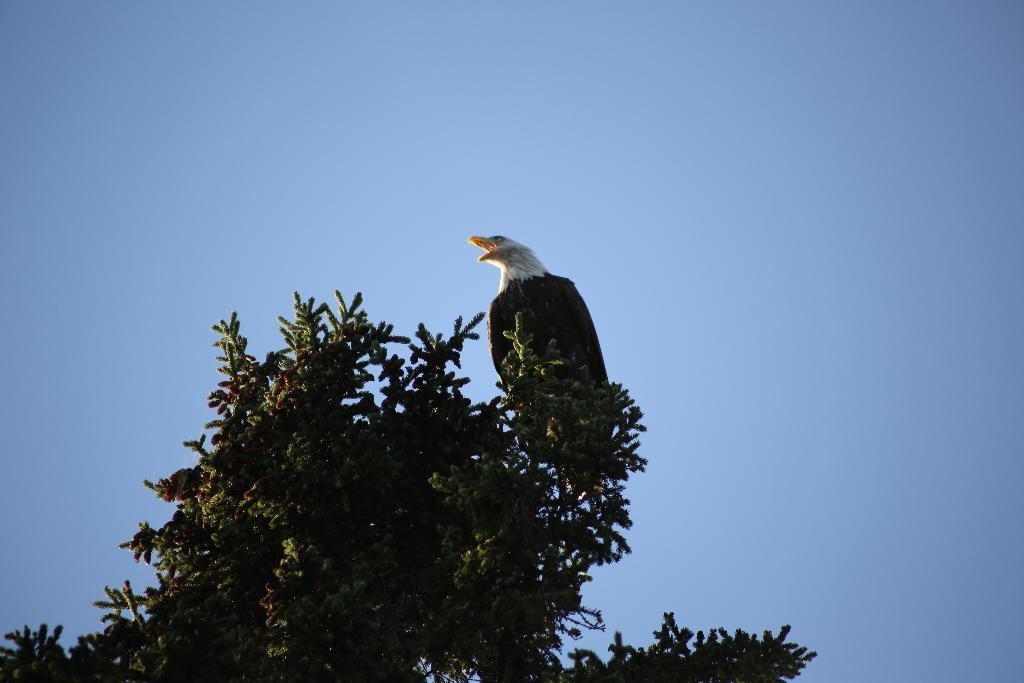What type of vegetation is visible in the image? There are branches of a tree in the image. What animal is sitting on the tree? There is an eagle sitting on the top of the tree. What is visible at the top of the image? The sky is visible at the top of the image. How many approvals does the wrist in the image have? There is no wrist or approval present in the image. 